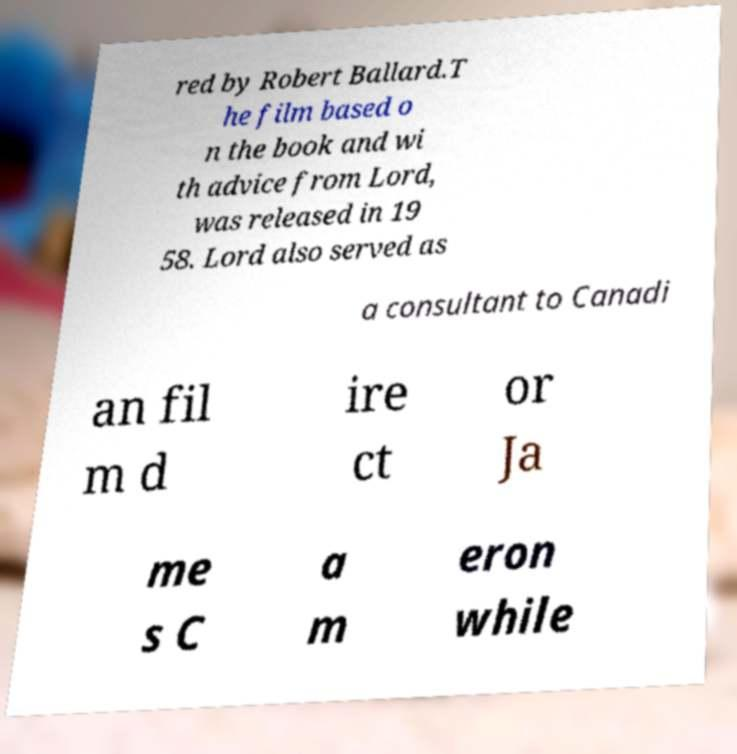There's text embedded in this image that I need extracted. Can you transcribe it verbatim? red by Robert Ballard.T he film based o n the book and wi th advice from Lord, was released in 19 58. Lord also served as a consultant to Canadi an fil m d ire ct or Ja me s C a m eron while 